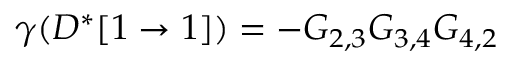Convert formula to latex. <formula><loc_0><loc_0><loc_500><loc_500>\gamma ( D ^ { * } [ 1 \rightarrow 1 ] ) = - G _ { 2 , 3 } G _ { 3 , 4 } G _ { 4 , 2 }</formula> 